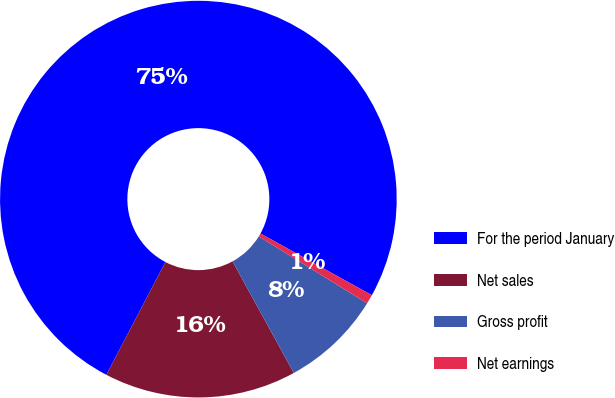Convert chart. <chart><loc_0><loc_0><loc_500><loc_500><pie_chart><fcel>For the period January<fcel>Net sales<fcel>Gross profit<fcel>Net earnings<nl><fcel>75.37%<fcel>15.67%<fcel>8.21%<fcel>0.75%<nl></chart> 